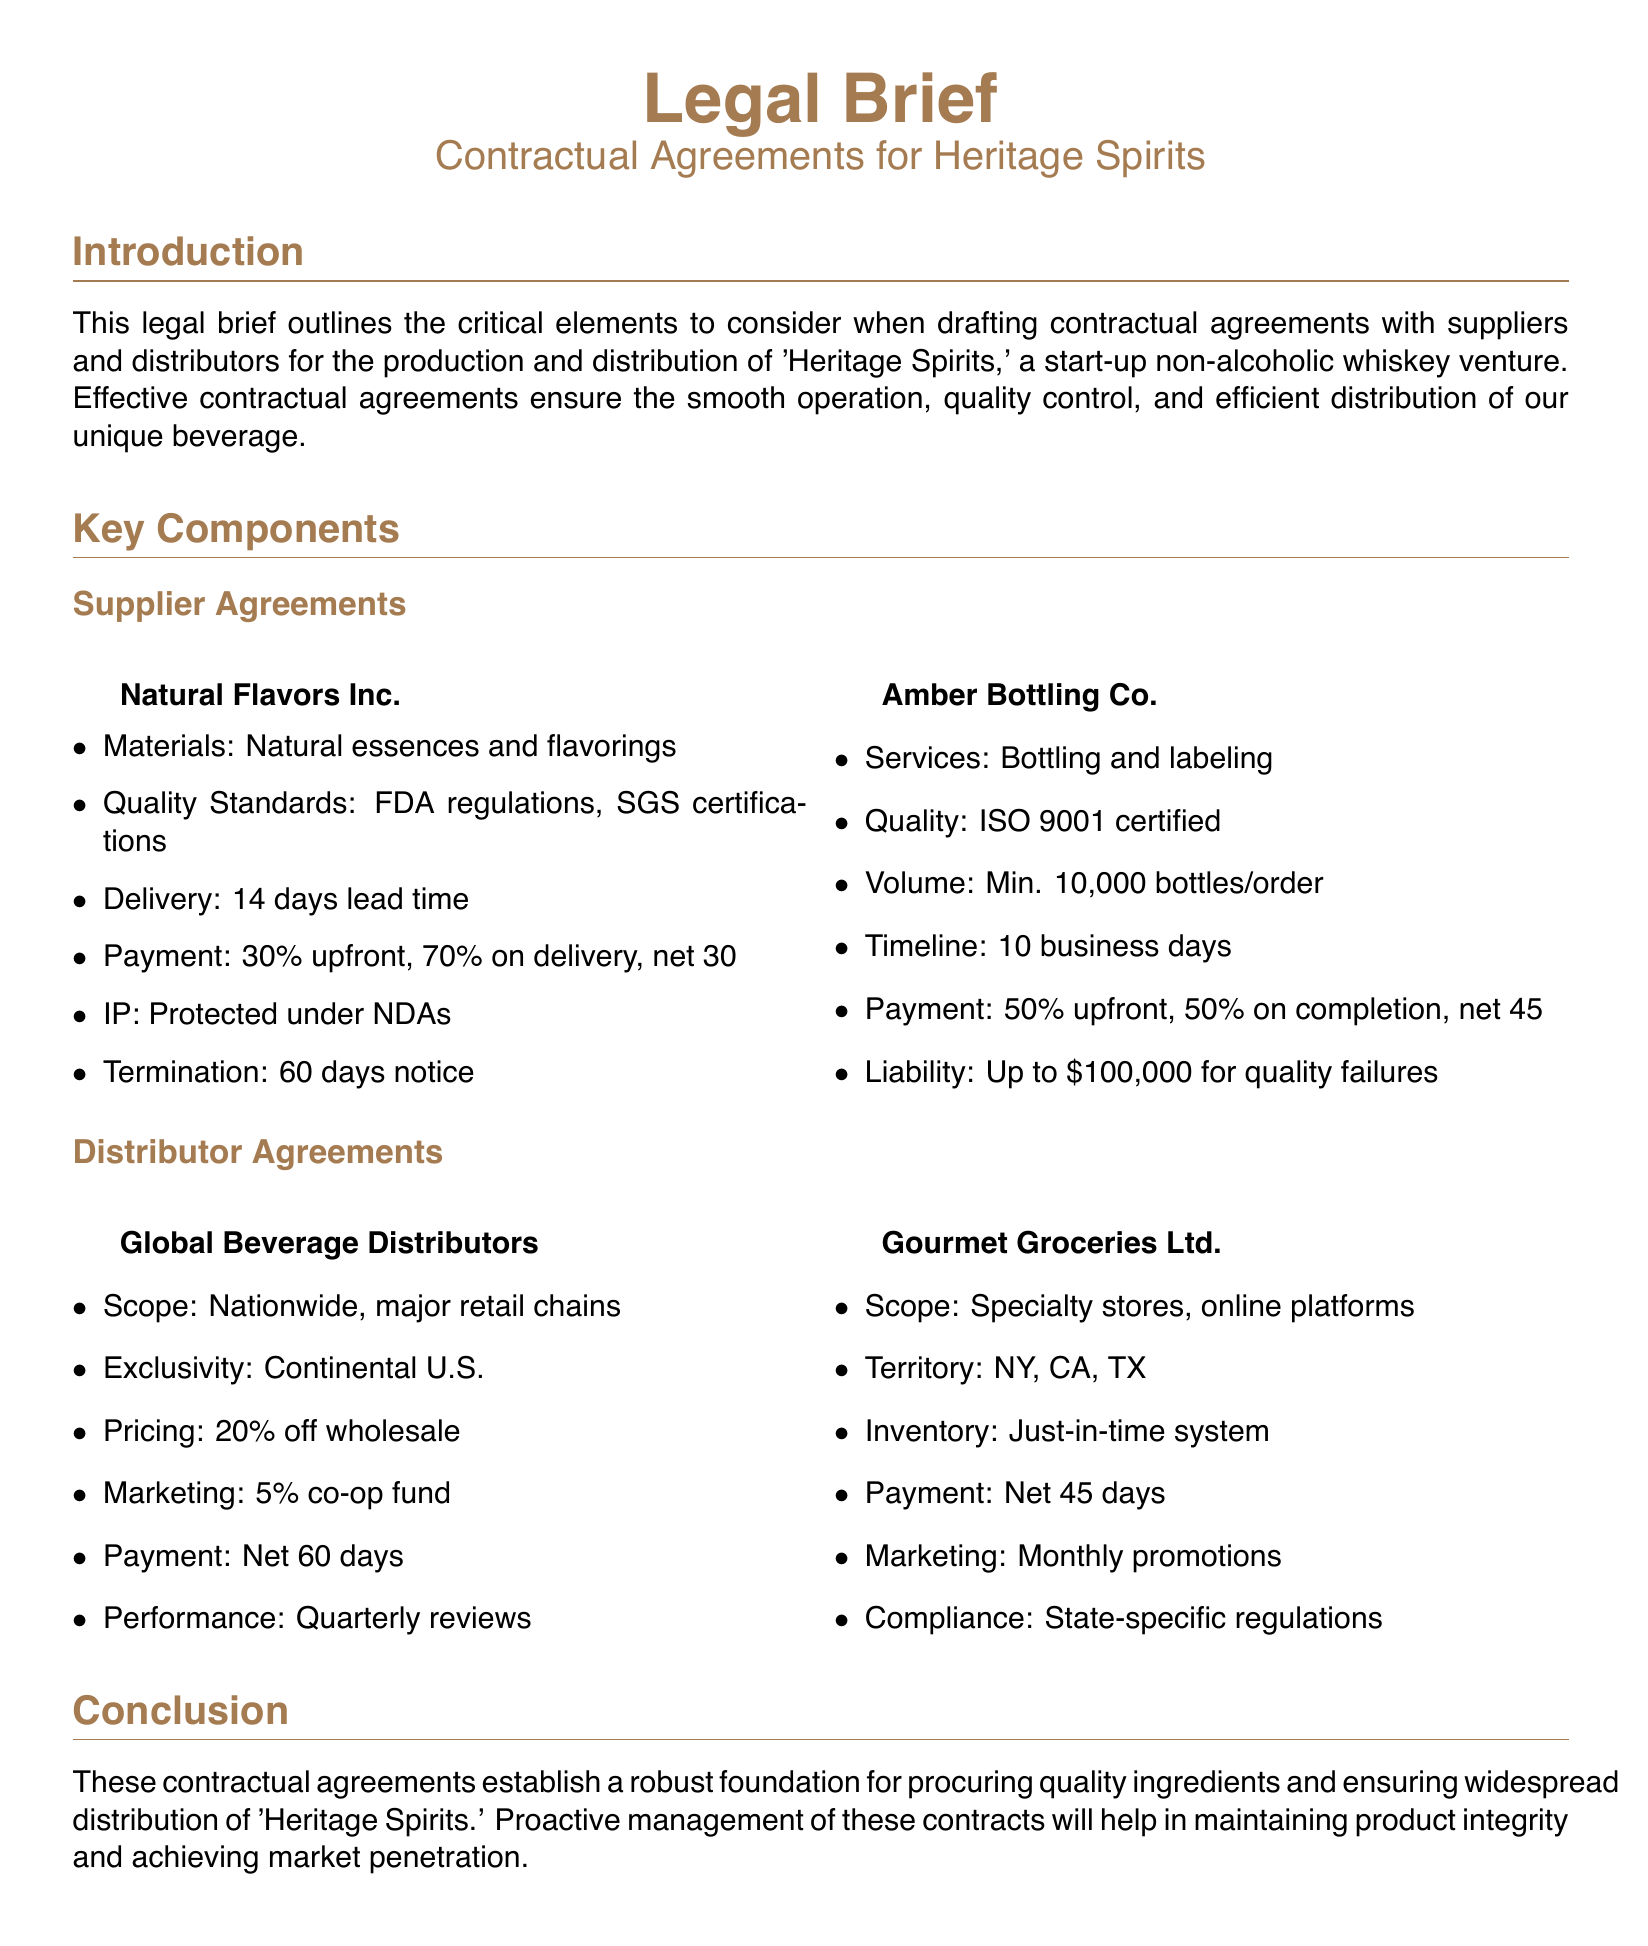What are the materials provided by Natural Flavors Inc.? The materials provided by Natural Flavors Inc. are natural essences and flavorings.
Answer: natural essences and flavorings What is the lead time for delivery from Natural Flavors Inc.? The lead time for delivery from Natural Flavors Inc. is specified as 14 days.
Answer: 14 days What is the minimum order volume required by Amber Bottling Co.? The minimum order volume required by Amber Bottling Co. is stated to be 10,000 bottles per order.
Answer: 10,000 bottles What percentage of the payment is required upfront for Global Beverage Distributors? The percentage of the payment required upfront for Global Beverage Distributors is 20 off wholesale.
Answer: 20 percent What certification must Amber Bottling Co. possess? Amber Bottling Co. must possess an ISO 9001 certification.
Answer: ISO 9001 certified What is the compliance requirement mentioned for Gourmet Groceries Ltd.? The compliance requirement mentioned for Gourmet Groceries Ltd. is adherence to state-specific regulations.
Answer: state-specific regulations What is the exclusivity territory for Global Beverage Distributors? The exclusivity territory for Global Beverage Distributors is the Continental U.S.
Answer: Continental U.S What type of beverages is being produced and distributed? The type of beverage being produced and distributed is 'Heritage Spirits', a non-alcoholic whiskey.
Answer: 'Heritage Spirits' What is the document type? The document type is a legal brief.
Answer: legal brief What element is emphasized in the conclusion of the document? The element emphasized in the conclusion is proactive management of contracts for maintaining product integrity.
Answer: proactive management of contracts 